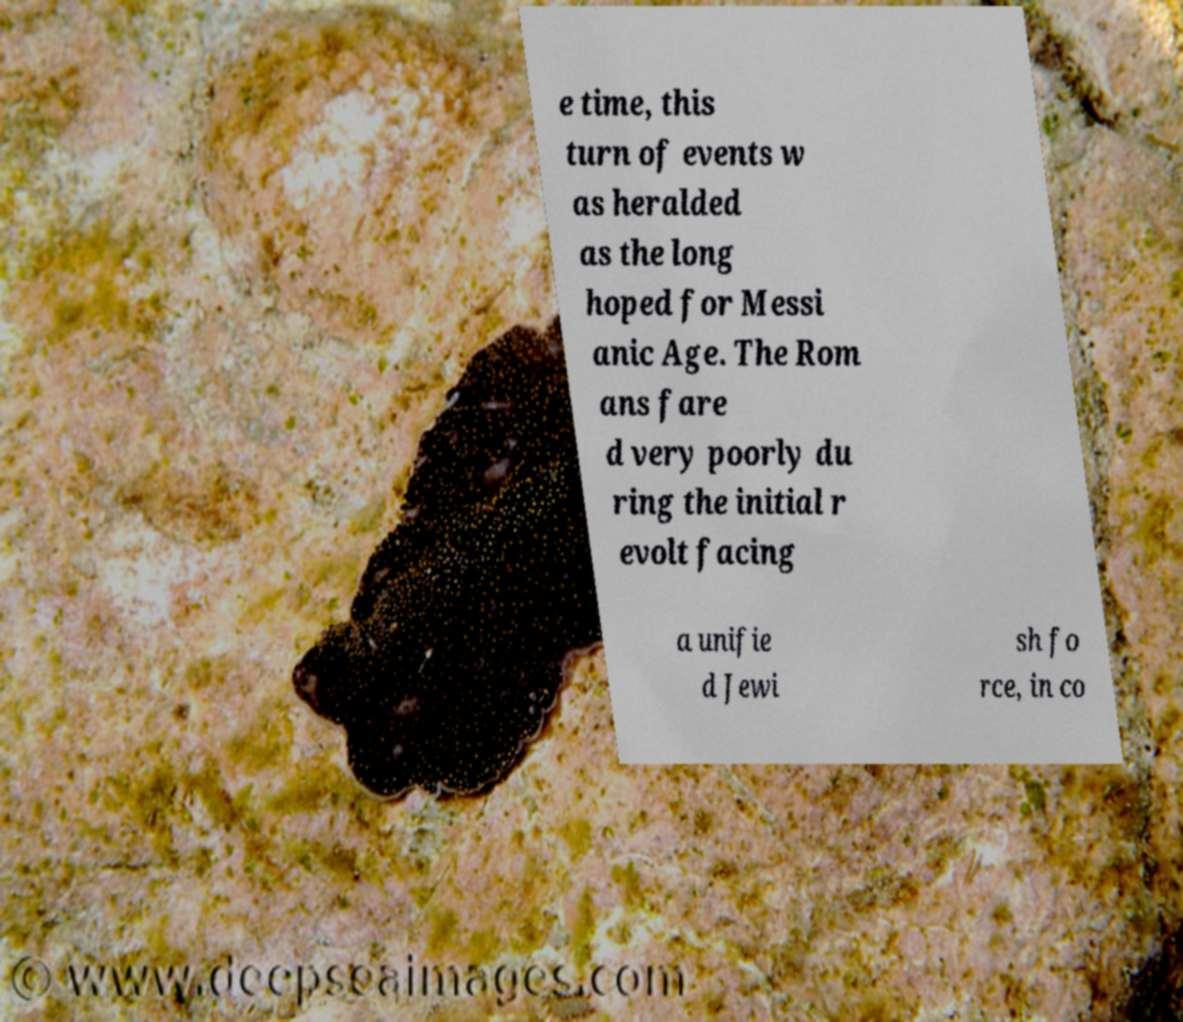Please identify and transcribe the text found in this image. e time, this turn of events w as heralded as the long hoped for Messi anic Age. The Rom ans fare d very poorly du ring the initial r evolt facing a unifie d Jewi sh fo rce, in co 